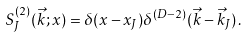<formula> <loc_0><loc_0><loc_500><loc_500>S _ { J } ^ { ( 2 ) } ( \vec { k } ; x ) = \delta ( x - x _ { J } ) \delta ^ { ( D - 2 ) } ( \vec { k } - \vec { k } _ { J } ) \, .</formula> 